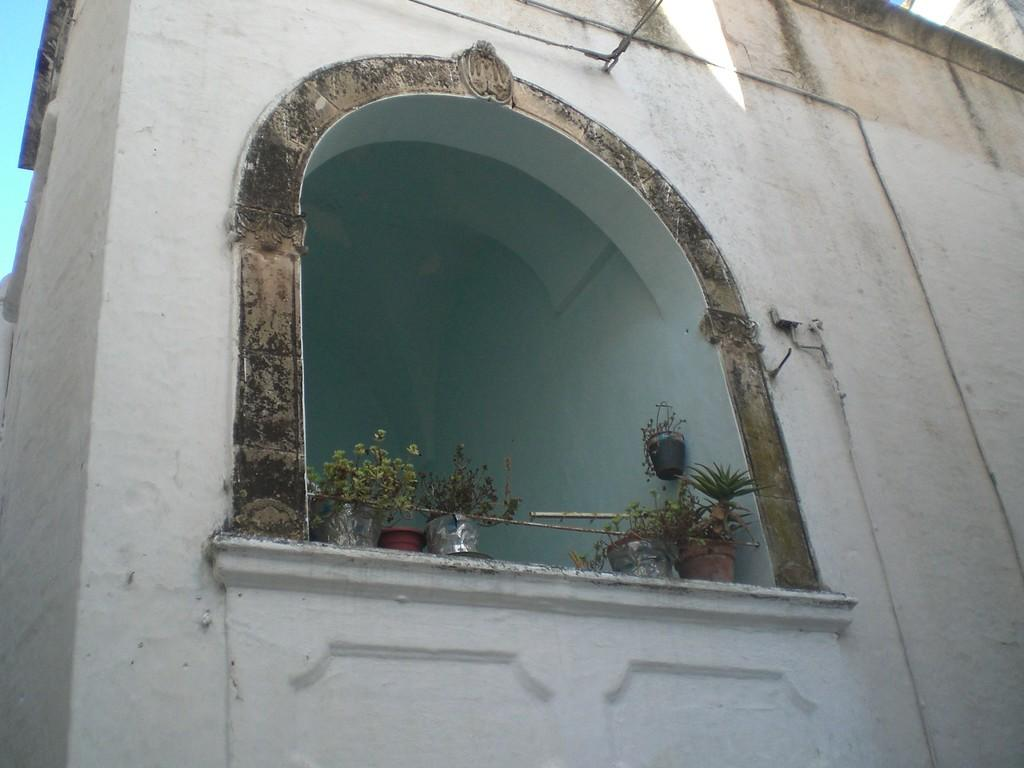What objects are present in the image related to plants? There are plant pots in the image. Where are the plant pots located? The plant pots are on a surface. What type of architectural feature can be seen in the image? There is an arch construction in the image. How many pencils are visible in the image? There are no pencils present in the image. 